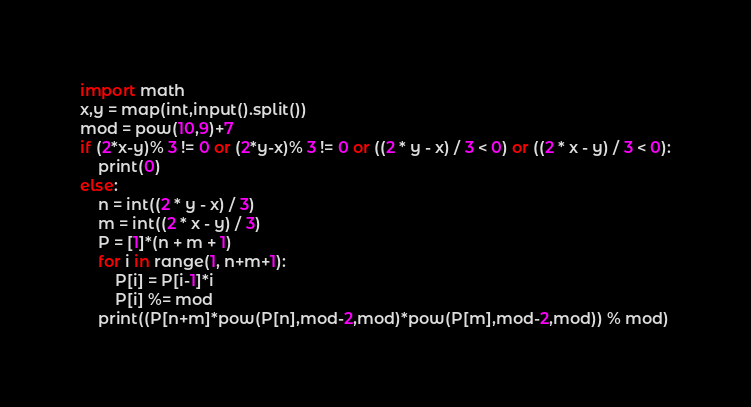<code> <loc_0><loc_0><loc_500><loc_500><_Python_>import math
x,y = map(int,input().split())
mod = pow(10,9)+7
if (2*x-y)% 3 != 0 or (2*y-x)% 3 != 0 or ((2 * y - x) / 3 < 0) or ((2 * x - y) / 3 < 0):
	print(0)
else:
	n = int((2 * y - x) / 3)
	m = int((2 * x - y) / 3)
	P = [1]*(n + m + 1)
	for i in range(1, n+m+1):
		P[i] = P[i-1]*i
		P[i] %= mod
	print((P[n+m]*pow(P[n],mod-2,mod)*pow(P[m],mod-2,mod)) % mod)</code> 